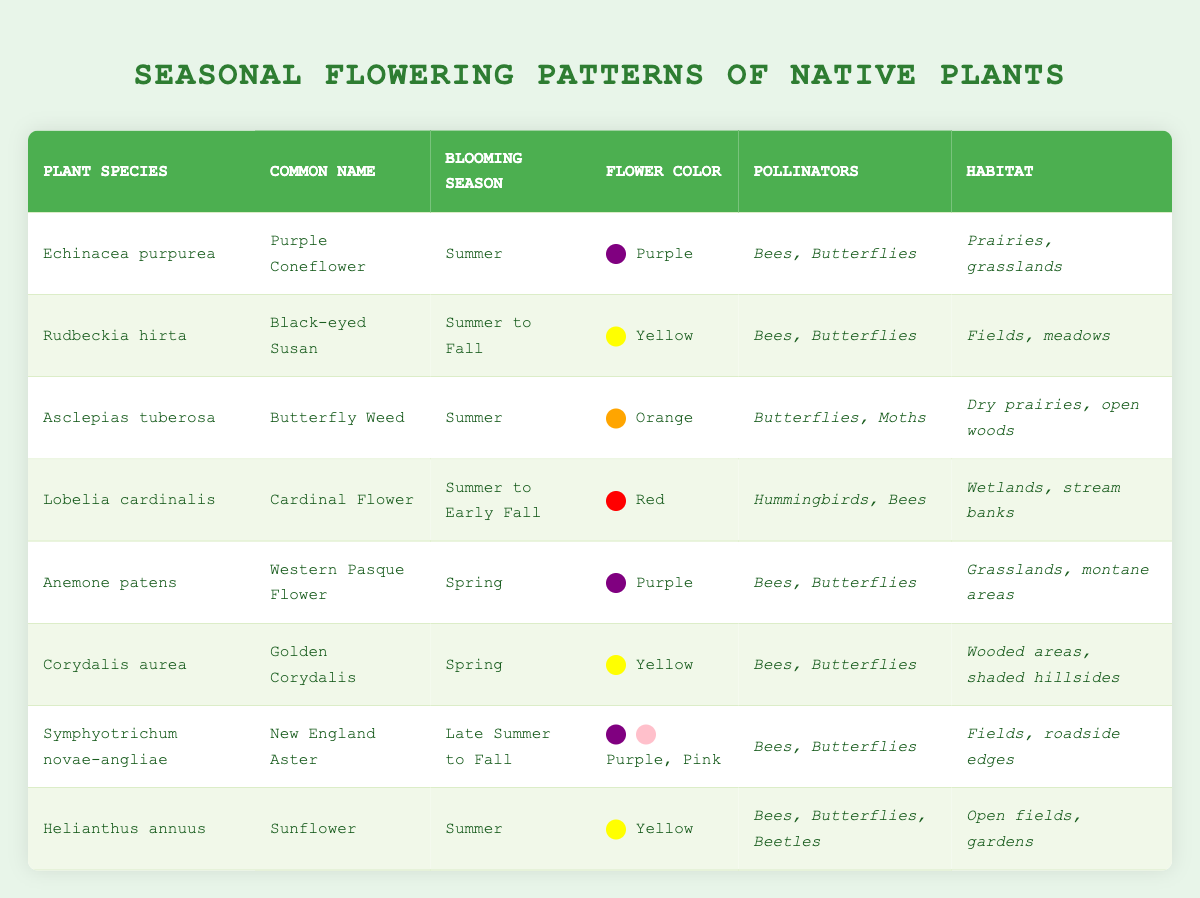What is the common name for the plant species Echinacea purpurea? The table lists the common name for Echinacea purpurea as "Purple Coneflower."
Answer: Purple Coneflower Which plants have a blooming season in summer? The table shows that the following plants bloom in summer: Echinacea purpurea, Asclepias tuberosa, Helianthus annuus, and Lobelia cardinalis.
Answer: Echinacea purpurea, Asclepias tuberosa, Helianthus annuus, Lobelia cardinalis Are there any red flowering plants listed? Reviewing the table, Lobelia cardinalis is the only plant listed with red flowers.
Answer: Yes How many different colors of flowers are present in the table? The table indicates the following flower colors: Purple, Yellow, Orange, Red, and Pink. This results in a total of 5 different colors.
Answer: 5 What is the blooming season for the New England Aster? The table identifies the blooming season for Symphyotrichum novae-angliae (New England Aster) as "Late Summer to Fall."
Answer: Late Summer to Fall How many plants attract butterflies as pollinators? The table lists eight plants. Upon reviewing, the following plants attract butterflies: Echinacea purpurea, Rudbeckia hirta, Asclepias tuberosa, Lobelia cardinalis, Anemone patens, Corydalis aurea, Symphyotrichum novae-angliae, and Helianthus annuus. Counting these gives a total of 8.
Answer: 8 Which plant has a blooming season that extends into the fall? By checking the blooming seasons listed, Rudbeckia hirta, Lobelia cardinalis, and Symphyotrichum novae-angliae all have blooming seasons that extend into the fall, either starting in summer or later.
Answer: Rudbeckia hirta, Lobelia cardinalis, Symphyotrichum novae-angliae What are the habitats of the plants that bloom in spring? The table indicates that Anemone patens is found in grasslands and montane areas, and Corydalis aurea is found in wooded areas and shaded hillsides. Therefore, the habitats are grasslands, montane areas, wooded areas, and shaded hillsides.
Answer: Grasslands, montane areas, wooded areas, shaded hillsides Which plant species attracts the most diverse group of pollinators? From the table, Helianthus annuus attracts three pollinators: Bees, Butterflies, and Beetles, making it the plant with the most diverse pollinator group.
Answer: Helianthus annuus 